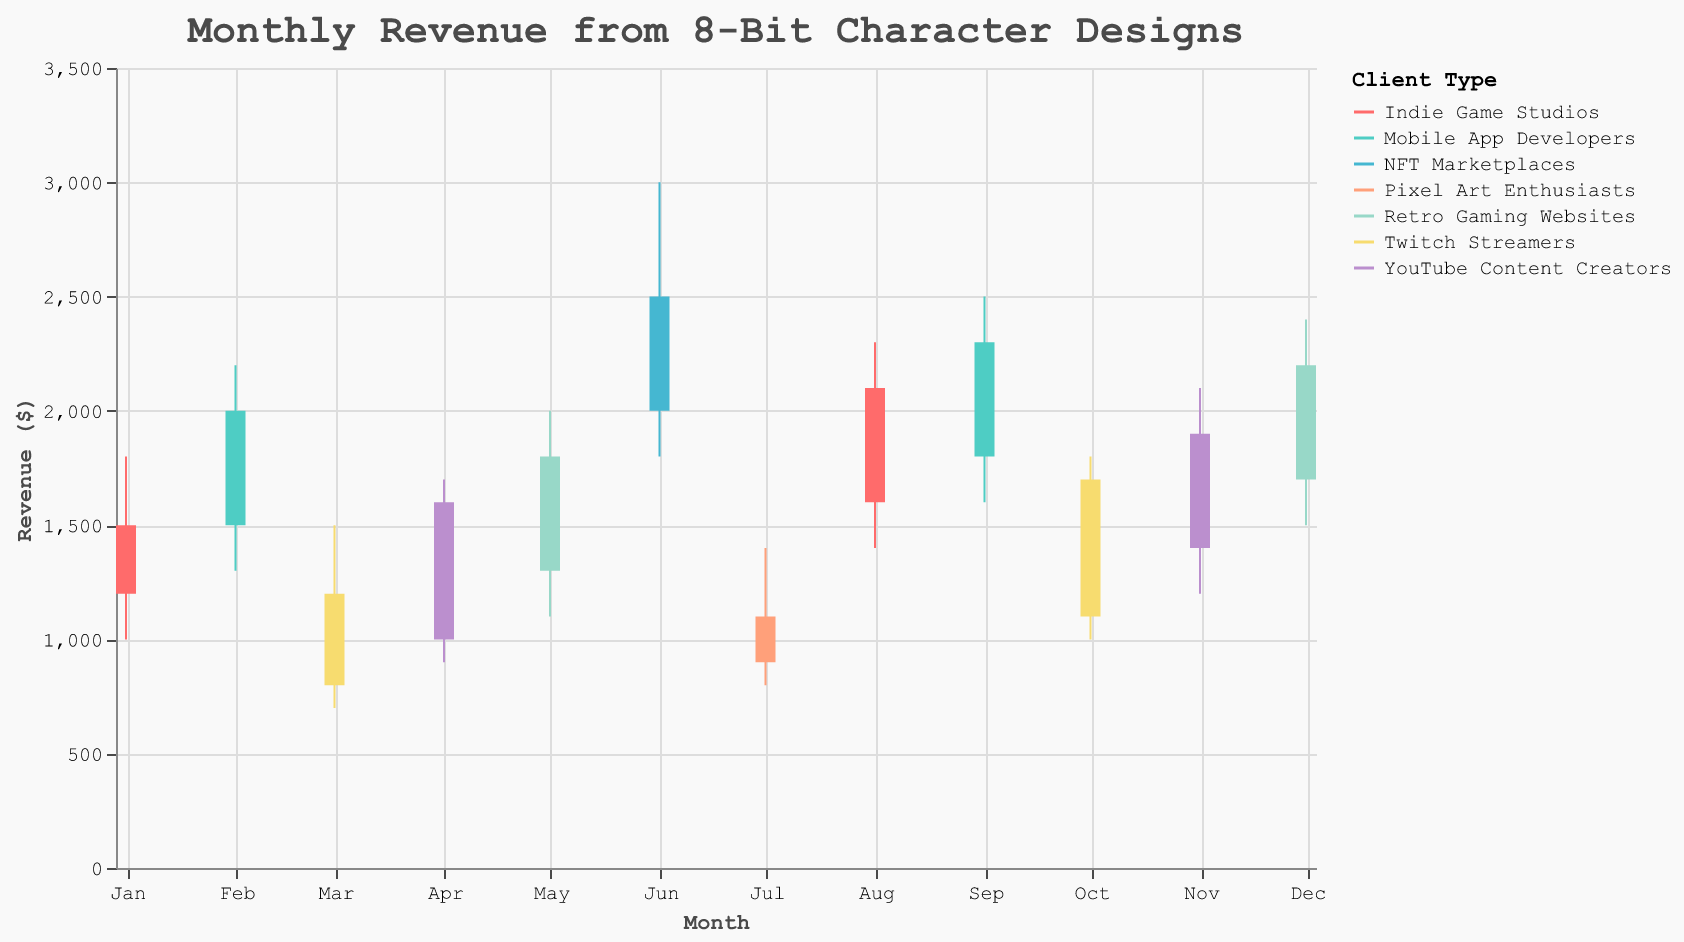Which month had the highest revenue from the NFTs Marketplaces? In the figure, locate the revenue values for the NFTs Marketplaces for each month and identify the highest close value. June had a close value of $2500, and no other month matches or surpasses this value for the NFTs Marketplaces.
Answer: June What was the revenue range for Indie Game Studios in August 2023? The revenue range is the difference between the high and low values. For Indie Game Studios in August 2023, substract the low value ($1400) from the high value ($2300). So, $2300 - $1400 = $900
Answer: $900 Which client type contributed the most to revenue in November 2023? By examining the close values for each client type in November 2023, YouTube Content Creators had a close value of $1900, which is higher than other client types in the same month.
Answer: YouTube Content Creators Compare the opening revenue of Twitch Streamers between March and October 2023. Which month had the higher opening revenue? Compare the open values for Twitch Streamers in March (800) and October (1100). October's opening revenue (1100) is higher than March (800).
Answer: October In which month did Mobile App Developers see the greatest increase in revenue between the open and close values? Calculate the differences between the open and close values for each month with Mobile App Developers. For February: $2000 - $1500 = $500; for September: $2300 - $1800 = $500. Both months see the same increase of $500. Therefore, both February and September applied.
Answer: February & September What is the average close value from January to December 2023? Calculate the average of the close values by summing up all monthly close values and dividing by 12. (1500 + 2000 + 1200 + 1600 + 1800 + 2500 + 1100 + 2100 + 2300 + 1700 + 1900 + 2200) / 12 = 20900 / 12 = 1741.67
Answer: 1741.67 Which month shows the lowest close value for Pixel Art Enthusiasts? Find the month with Pixel Art Enthusiasts and check the close value. July has a close value of $1100, which is the lowest for this client type.
Answer: July How did the high value of YouTube Content Creators in November 2023 compare to their high value in April 2023? Compare the high values in both months. November: $2100, April: $1700. The high value increased from April to November by $400 (2100 - 1700 = 400).
Answer: The high value increased by $400 